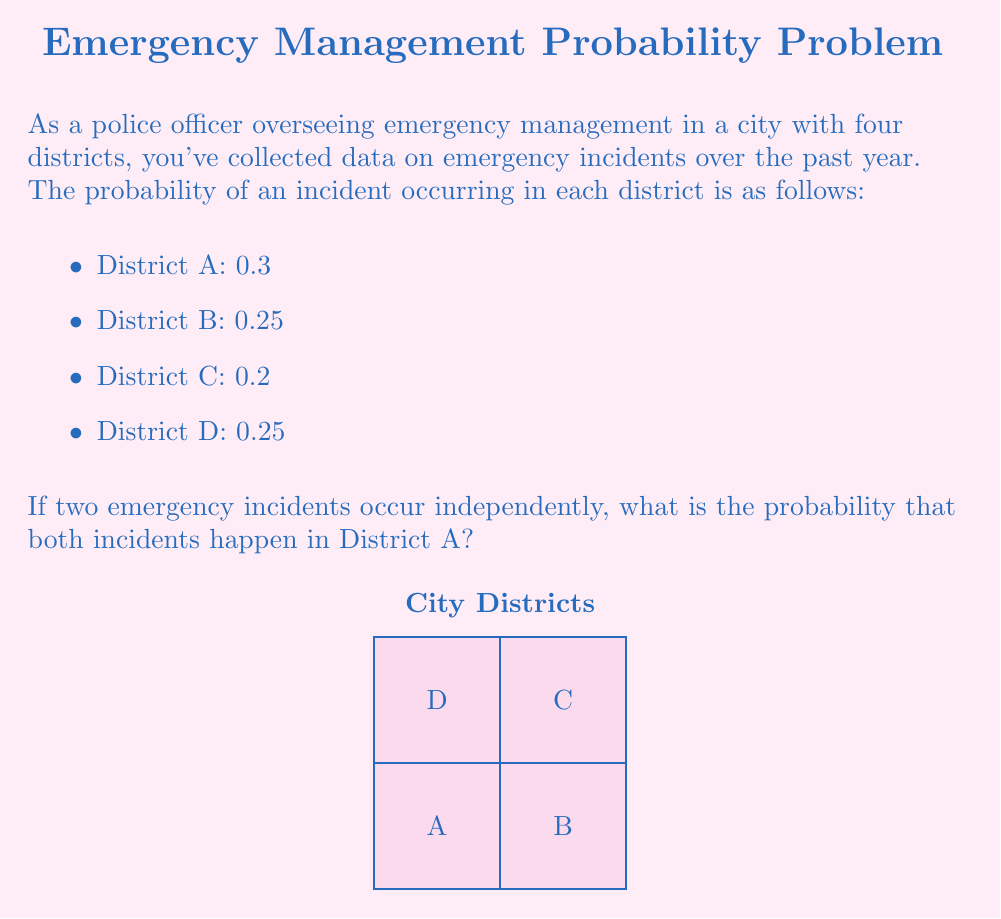Can you answer this question? To solve this problem, we need to use the concept of independent events and multiplication rule of probability.

1) The probability of an incident occurring in District A is 0.3.

2) For two independent incidents, we need to calculate the probability of both occurring in District A.

3) Since the events are independent, we multiply the probabilities:

   $$P(\text{Both in A}) = P(\text{First in A}) \times P(\text{Second in A})$$

4) Substituting the given probability:

   $$P(\text{Both in A}) = 0.3 \times 0.3 = 0.09$$

5) Therefore, the probability that both incidents occur in District A is 0.09 or 9%.

This calculation helps in resource allocation and preparedness for multiple simultaneous emergencies in a single district.
Answer: $0.09$ 